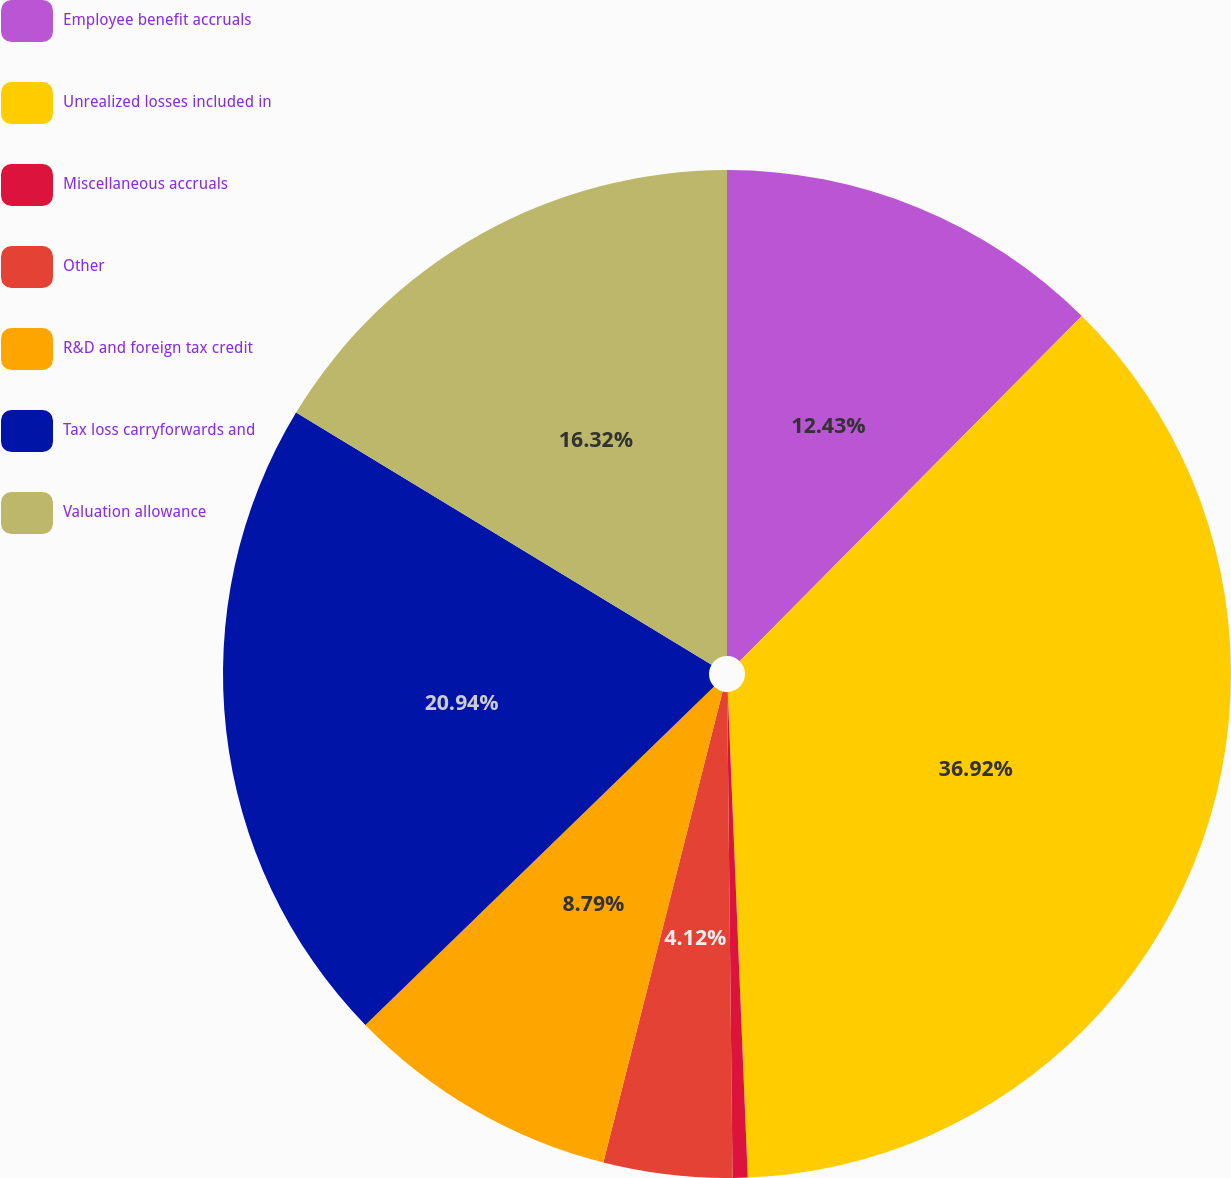Convert chart to OTSL. <chart><loc_0><loc_0><loc_500><loc_500><pie_chart><fcel>Employee benefit accruals<fcel>Unrealized losses included in<fcel>Miscellaneous accruals<fcel>Other<fcel>R&D and foreign tax credit<fcel>Tax loss carryforwards and<fcel>Valuation allowance<nl><fcel>12.43%<fcel>36.91%<fcel>0.48%<fcel>4.12%<fcel>8.79%<fcel>20.94%<fcel>16.32%<nl></chart> 